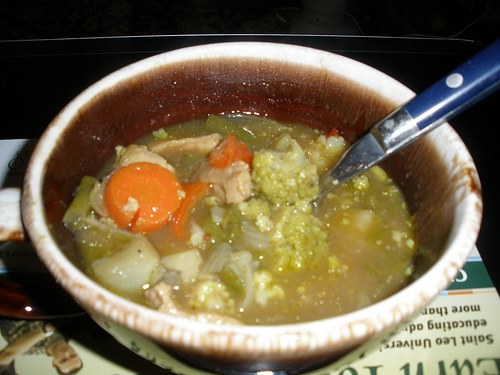What is the vegetable to the left of the soup in the bottom of the picture? The vegetable to the left of the soup at the bottom of the picture is an onion. 